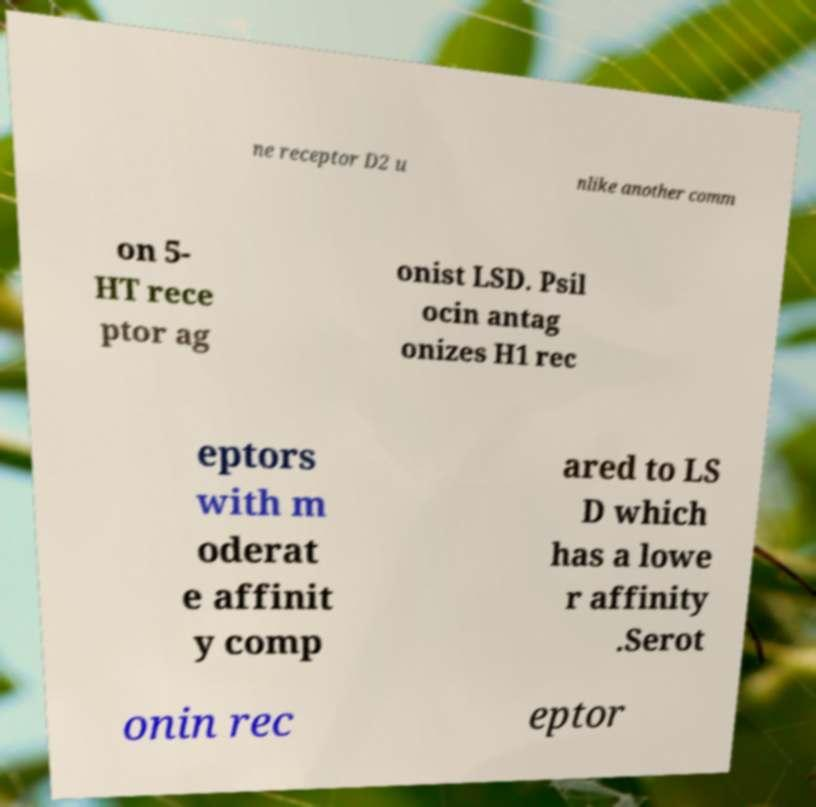Can you read and provide the text displayed in the image?This photo seems to have some interesting text. Can you extract and type it out for me? ne receptor D2 u nlike another comm on 5- HT rece ptor ag onist LSD. Psil ocin antag onizes H1 rec eptors with m oderat e affinit y comp ared to LS D which has a lowe r affinity .Serot onin rec eptor 